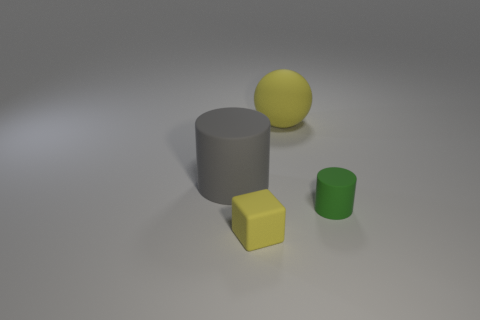How many yellow objects have the same shape as the green rubber object?
Provide a short and direct response. 0. Are there an equal number of big yellow rubber balls that are to the right of the gray rubber object and small shiny cylinders?
Make the answer very short. No. Are there any other things that are the same size as the gray rubber thing?
Make the answer very short. Yes. What shape is the gray matte object that is the same size as the ball?
Your answer should be compact. Cylinder. Are there any tiny yellow matte objects that have the same shape as the big gray object?
Provide a succinct answer. No. There is a cylinder in front of the rubber cylinder that is on the left side of the big yellow sphere; are there any yellow matte objects on the right side of it?
Your answer should be compact. No. Are there more big gray things that are right of the large matte cylinder than yellow rubber blocks on the left side of the rubber sphere?
Your answer should be compact. No. What is the material of the yellow block that is the same size as the green cylinder?
Your answer should be compact. Rubber. What number of big things are blue cylinders or yellow rubber balls?
Offer a terse response. 1. Is the tiny yellow thing the same shape as the big yellow matte thing?
Your answer should be very brief. No. 